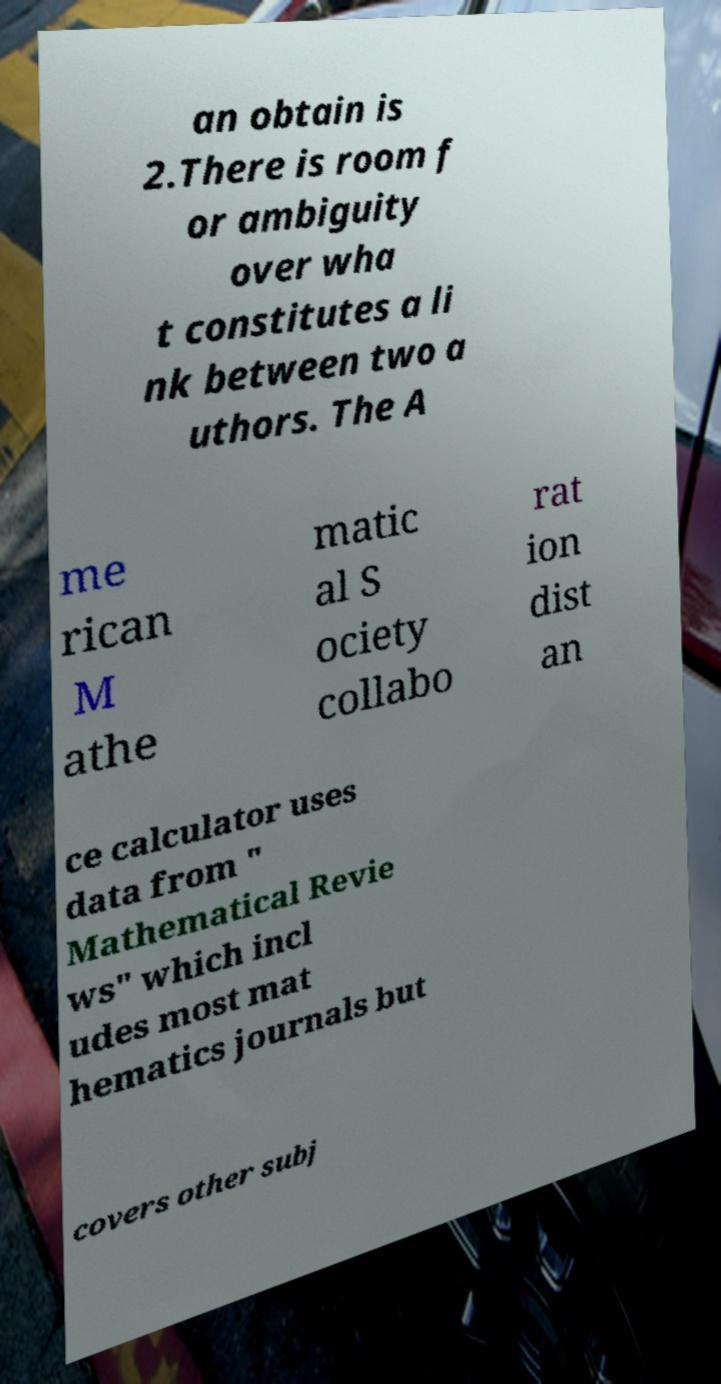What messages or text are displayed in this image? I need them in a readable, typed format. an obtain is 2.There is room f or ambiguity over wha t constitutes a li nk between two a uthors. The A me rican M athe matic al S ociety collabo rat ion dist an ce calculator uses data from " Mathematical Revie ws" which incl udes most mat hematics journals but covers other subj 